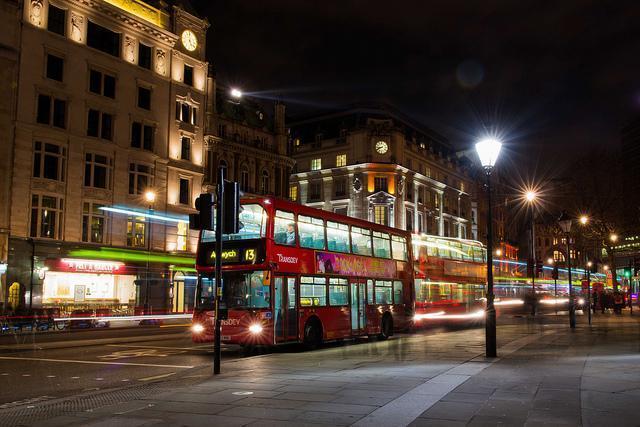How many floors does the bus have?
Give a very brief answer. 2. 